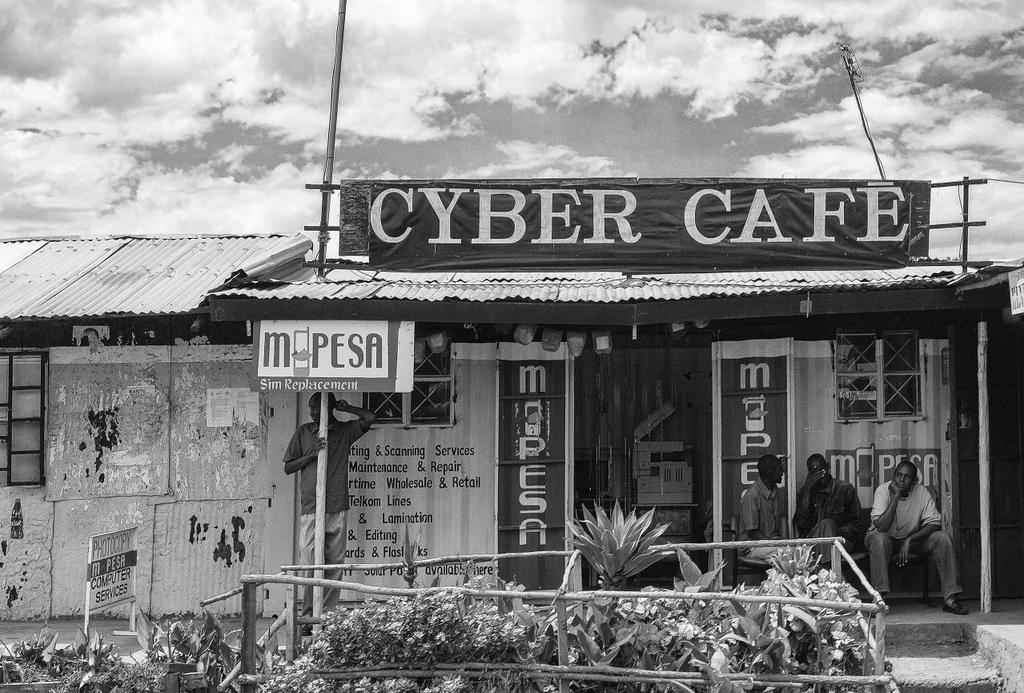<image>
Present a compact description of the photo's key features. A black and white photo of a cyber cafe and sim replacement store sits in front of clouds. 